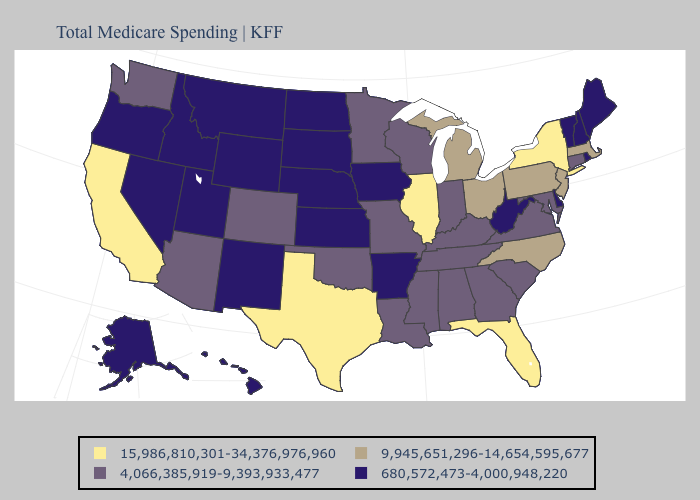Name the states that have a value in the range 4,066,385,919-9,393,933,477?
Keep it brief. Alabama, Arizona, Colorado, Connecticut, Georgia, Indiana, Kentucky, Louisiana, Maryland, Minnesota, Mississippi, Missouri, Oklahoma, South Carolina, Tennessee, Virginia, Washington, Wisconsin. What is the lowest value in the West?
Keep it brief. 680,572,473-4,000,948,220. Does Oklahoma have a higher value than Colorado?
Concise answer only. No. What is the lowest value in the MidWest?
Keep it brief. 680,572,473-4,000,948,220. Among the states that border Kentucky , which have the highest value?
Give a very brief answer. Illinois. Which states hav the highest value in the MidWest?
Write a very short answer. Illinois. Does South Dakota have the same value as Pennsylvania?
Keep it brief. No. Name the states that have a value in the range 4,066,385,919-9,393,933,477?
Concise answer only. Alabama, Arizona, Colorado, Connecticut, Georgia, Indiana, Kentucky, Louisiana, Maryland, Minnesota, Mississippi, Missouri, Oklahoma, South Carolina, Tennessee, Virginia, Washington, Wisconsin. What is the value of Maryland?
Quick response, please. 4,066,385,919-9,393,933,477. How many symbols are there in the legend?
Keep it brief. 4. Name the states that have a value in the range 15,986,810,301-34,376,976,960?
Short answer required. California, Florida, Illinois, New York, Texas. Name the states that have a value in the range 4,066,385,919-9,393,933,477?
Concise answer only. Alabama, Arizona, Colorado, Connecticut, Georgia, Indiana, Kentucky, Louisiana, Maryland, Minnesota, Mississippi, Missouri, Oklahoma, South Carolina, Tennessee, Virginia, Washington, Wisconsin. What is the lowest value in the USA?
Write a very short answer. 680,572,473-4,000,948,220. Among the states that border Mississippi , does Arkansas have the highest value?
Keep it brief. No. Does New Jersey have the highest value in the USA?
Short answer required. No. 